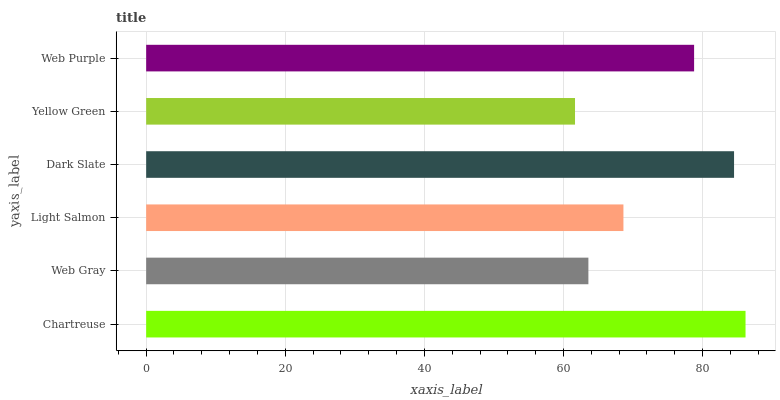Is Yellow Green the minimum?
Answer yes or no. Yes. Is Chartreuse the maximum?
Answer yes or no. Yes. Is Web Gray the minimum?
Answer yes or no. No. Is Web Gray the maximum?
Answer yes or no. No. Is Chartreuse greater than Web Gray?
Answer yes or no. Yes. Is Web Gray less than Chartreuse?
Answer yes or no. Yes. Is Web Gray greater than Chartreuse?
Answer yes or no. No. Is Chartreuse less than Web Gray?
Answer yes or no. No. Is Web Purple the high median?
Answer yes or no. Yes. Is Light Salmon the low median?
Answer yes or no. Yes. Is Web Gray the high median?
Answer yes or no. No. Is Web Purple the low median?
Answer yes or no. No. 